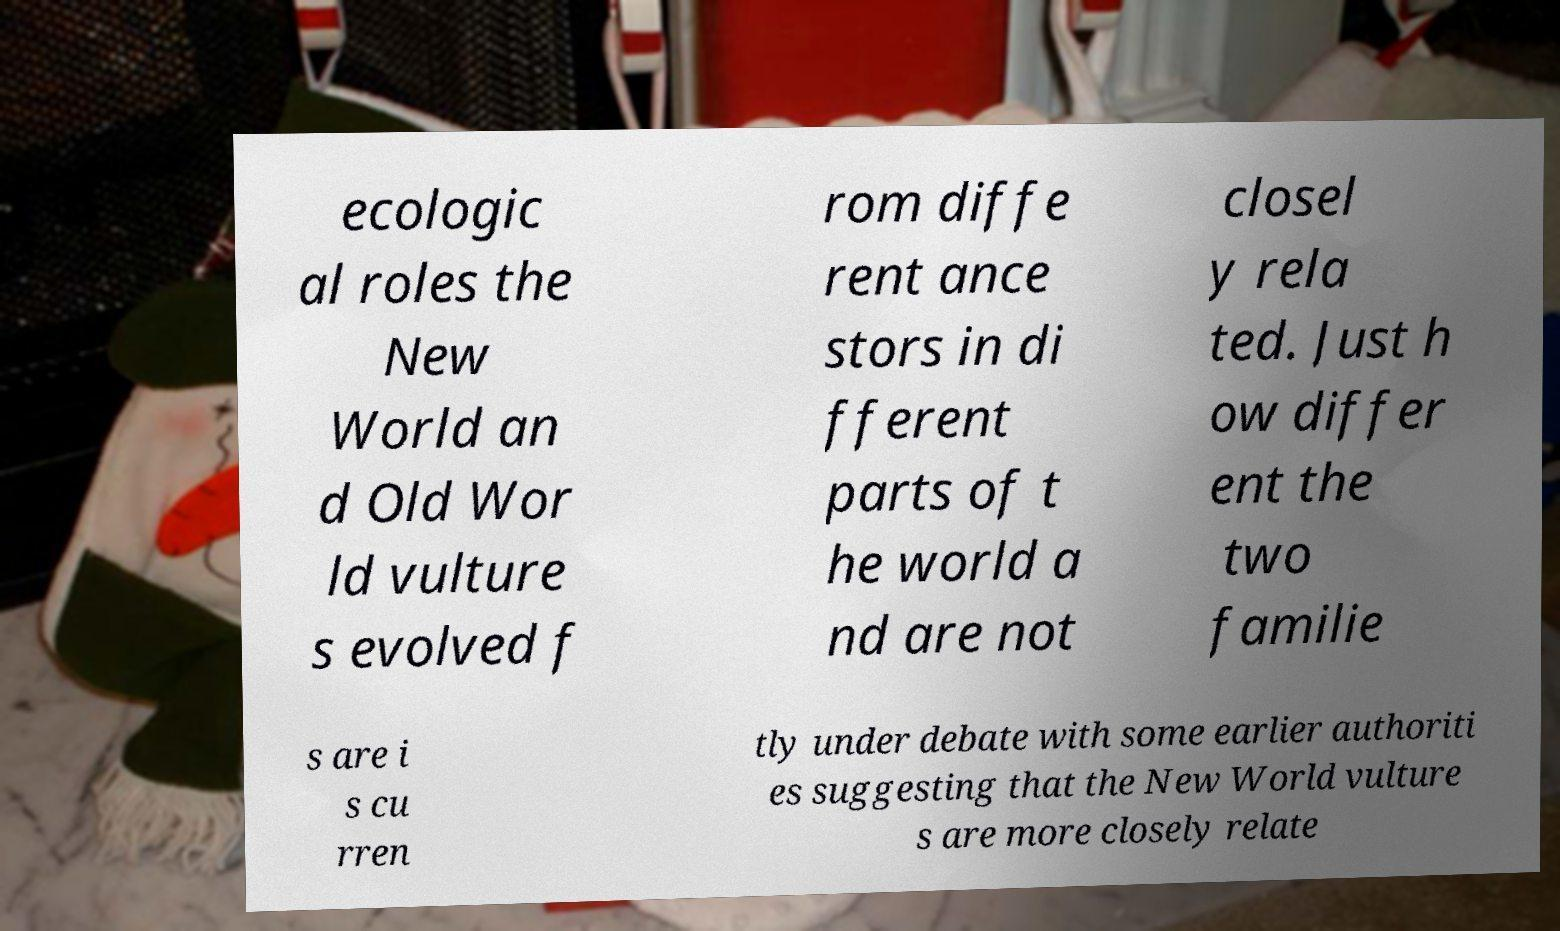What messages or text are displayed in this image? I need them in a readable, typed format. ecologic al roles the New World an d Old Wor ld vulture s evolved f rom diffe rent ance stors in di fferent parts of t he world a nd are not closel y rela ted. Just h ow differ ent the two familie s are i s cu rren tly under debate with some earlier authoriti es suggesting that the New World vulture s are more closely relate 